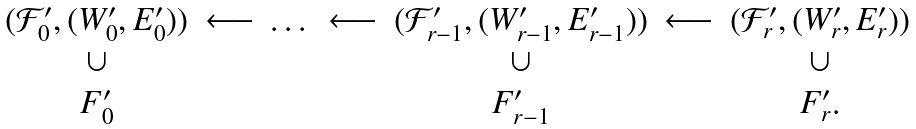Convert formula to latex. <formula><loc_0><loc_0><loc_500><loc_500>\begin{array} { c c c c c c c } ( { \mathcal { F } } _ { 0 } ^ { \prime } , ( W _ { 0 } ^ { \prime } , E _ { 0 } ^ { \prime } ) ) & \longleftarrow & \dots & \longleftarrow & ( { \mathcal { F } } _ { r - 1 } ^ { \prime } , ( W _ { r - 1 } ^ { \prime } , E _ { r - 1 } ^ { \prime } ) ) & \longleftarrow & ( { \mathcal { F } } _ { r } ^ { \prime } , ( W _ { r } ^ { \prime } , E _ { r } ^ { \prime } ) ) \\ \cup & & & & \cup & & \cup \\ F _ { 0 } ^ { \prime } & & & & F _ { r - 1 } ^ { \prime } & & F _ { r } ^ { \prime } . \end{array}</formula> 